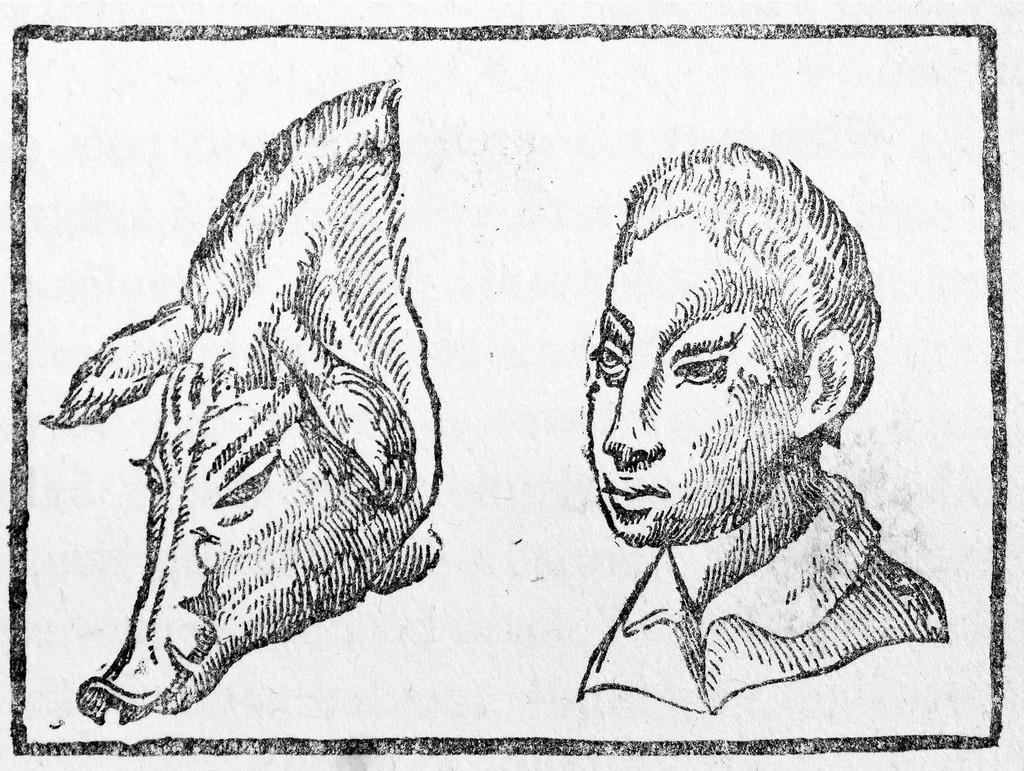What type of art can be seen in the image? There is an art of an animal and an art of a person in the image. What is the background color of the art? The art is on a white surface. How does the animal in the art sleep in the image? There is no indication of the animal sleeping in the image, as it is a static piece of art. 